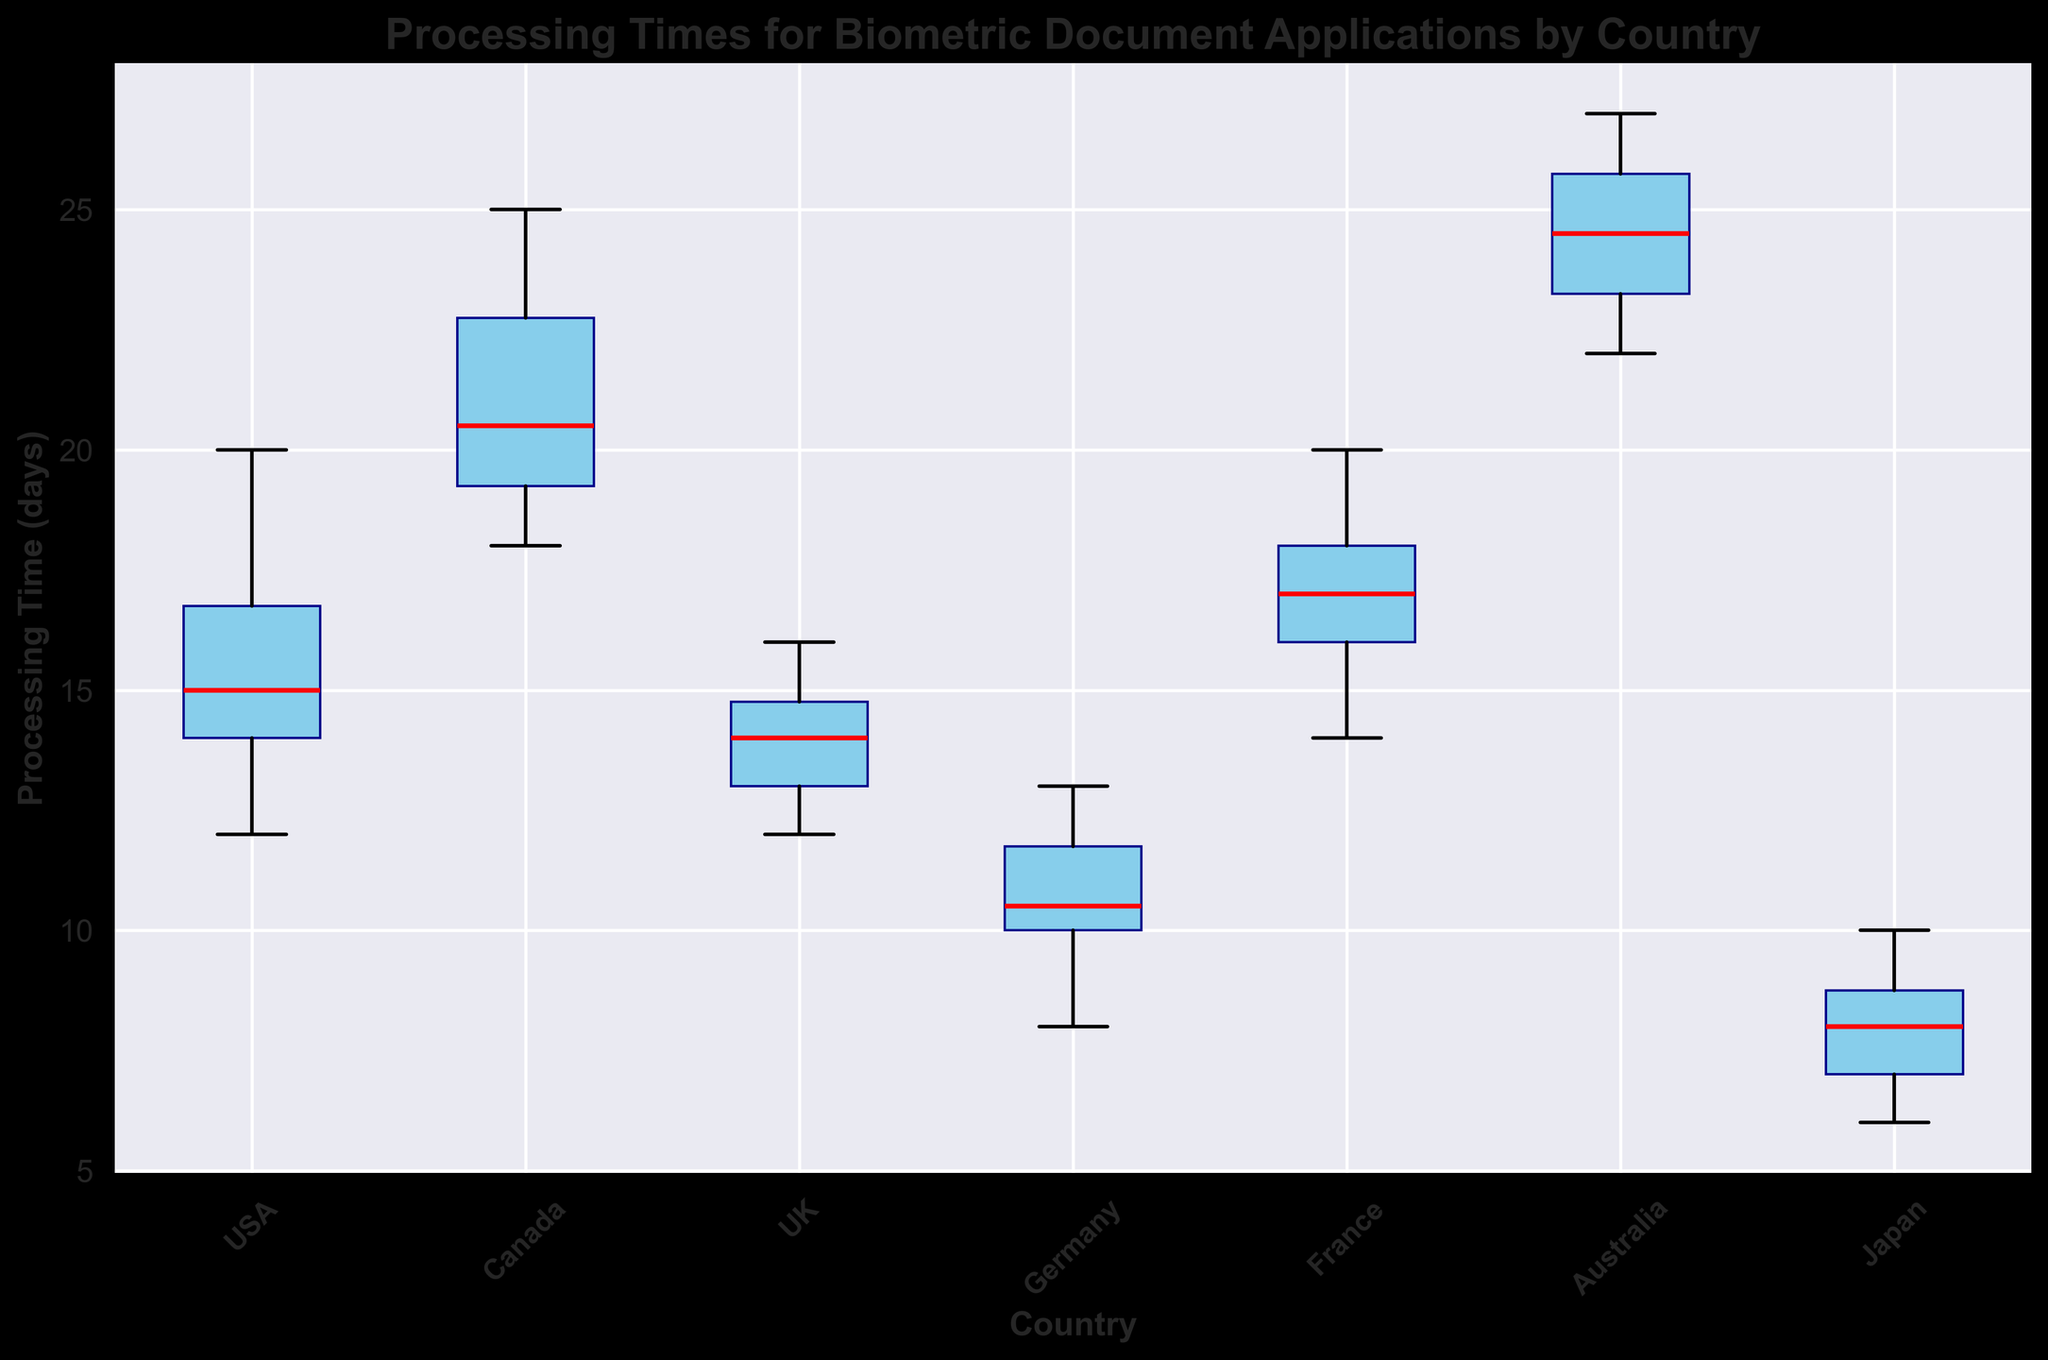What's the median processing time for the USA? To find the median processing time for the USA, we need to order the processing times and find the middle value. The ordered times are 12, 13, 14, 14, 15, 15, 16, 17, 18, 20. With 10 data points, the median is the average of the 5th and 6th values: (15 + 15) / 2 = 15.
Answer: 15 Which country has the highest median processing time? By comparing the medians of each country's box plot, we can determine the highest median. Australia has the highest median processing time, as its red line (median) is higher compared to other countries.
Answer: Australia How does Canada's interquartile range (IQR) compare to France's IQR? The IQR is the range between the first quartile (Q1) and the third quartile (Q3). Visually comparing the heights of the boxes for Canada and France, Canada's box appears taller, indicating a larger IQR.
Answer: Canada's IQR is larger Which country has the lowest minimum processing time? The minimum processing time is indicated by the lower whisker of the box plots. Japan's lower whisker is at the lowest position, corresponding to a processing time of 6.
Answer: Japan What's the difference between the median processing times of Germany and the UK? The median processing time for Germany is 10.5 (average of 10 and 11 from the box plot), and the median for the UK is 14. The difference is 14 - 10.5 = 3.5.
Answer: 3.5 What is the range of processing times for Australia? The range is the difference between the maximum and minimum values. Australia's maximum is 27 and its minimum is 22, so the range is 27 - 22 = 5.
Answer: 5 Identify the country with the smallest spread of processing times. The spread can be evaluated by comparing the total height of the whiskers and the box. Germany's combined height is the smallest, indicating the smallest spread.
Answer: Germany Which countries have outliers in their processing times? Outliers are indicated by red dots. The UK has two outliers at 12 and 16, which are not within the whiskers.
Answer: The UK 